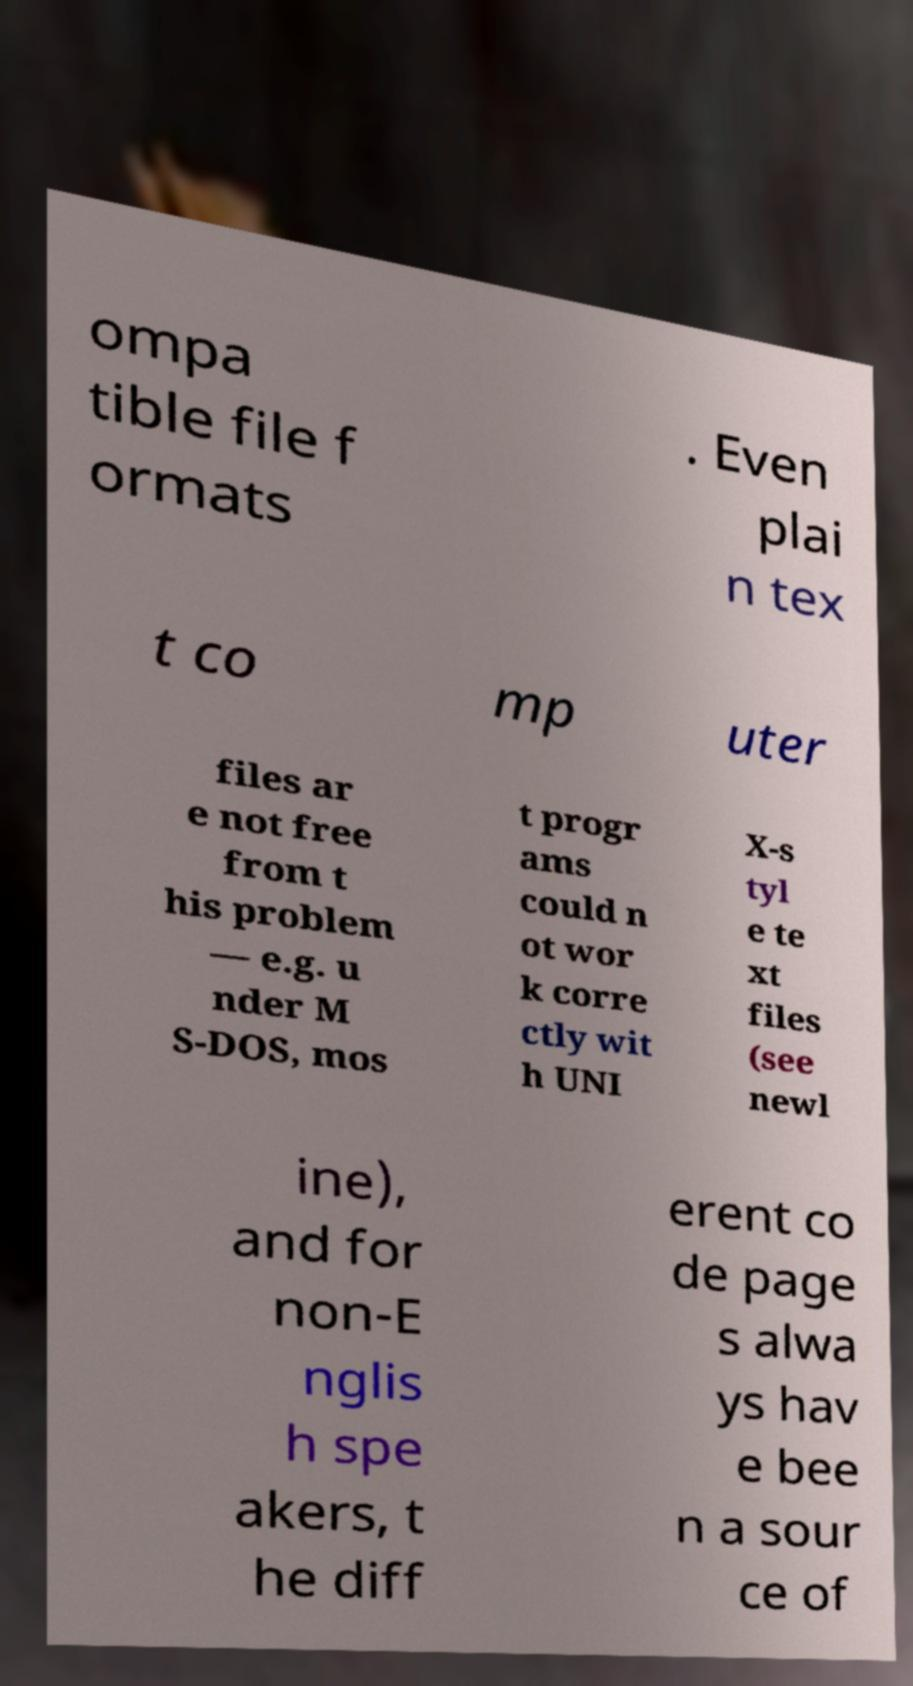Could you extract and type out the text from this image? ompa tible file f ormats . Even plai n tex t co mp uter files ar e not free from t his problem — e.g. u nder M S-DOS, mos t progr ams could n ot wor k corre ctly wit h UNI X-s tyl e te xt files (see newl ine), and for non-E nglis h spe akers, t he diff erent co de page s alwa ys hav e bee n a sour ce of 